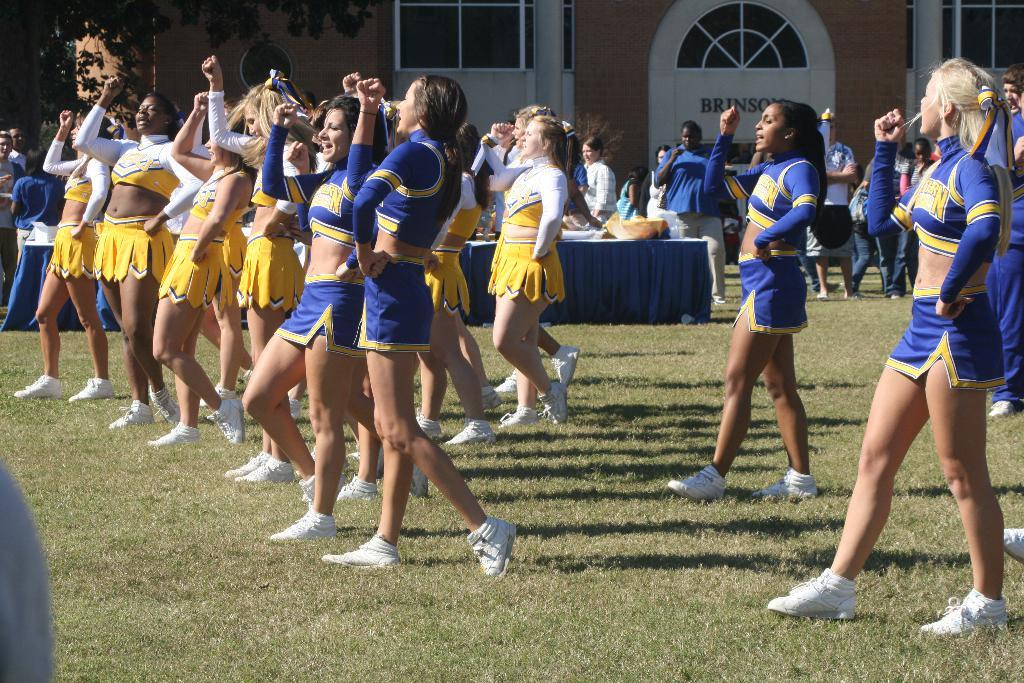Provide a one-sentence caption for the provided image. Many cheerleaders from LSU are lined up cheering. 